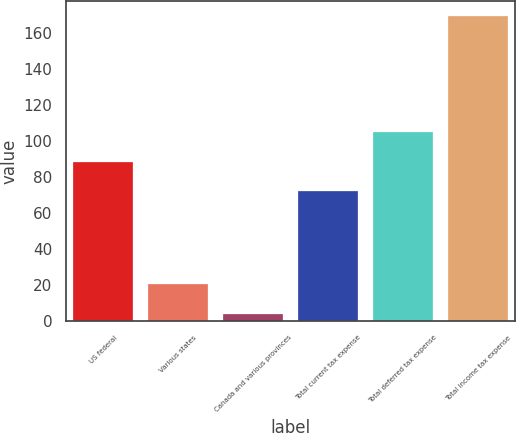<chart> <loc_0><loc_0><loc_500><loc_500><bar_chart><fcel>US federal<fcel>Various states<fcel>Canada and various provinces<fcel>Total current tax expense<fcel>Total deferred tax expense<fcel>Total income tax expense<nl><fcel>88.5<fcel>20.5<fcel>4<fcel>72<fcel>105<fcel>169<nl></chart> 